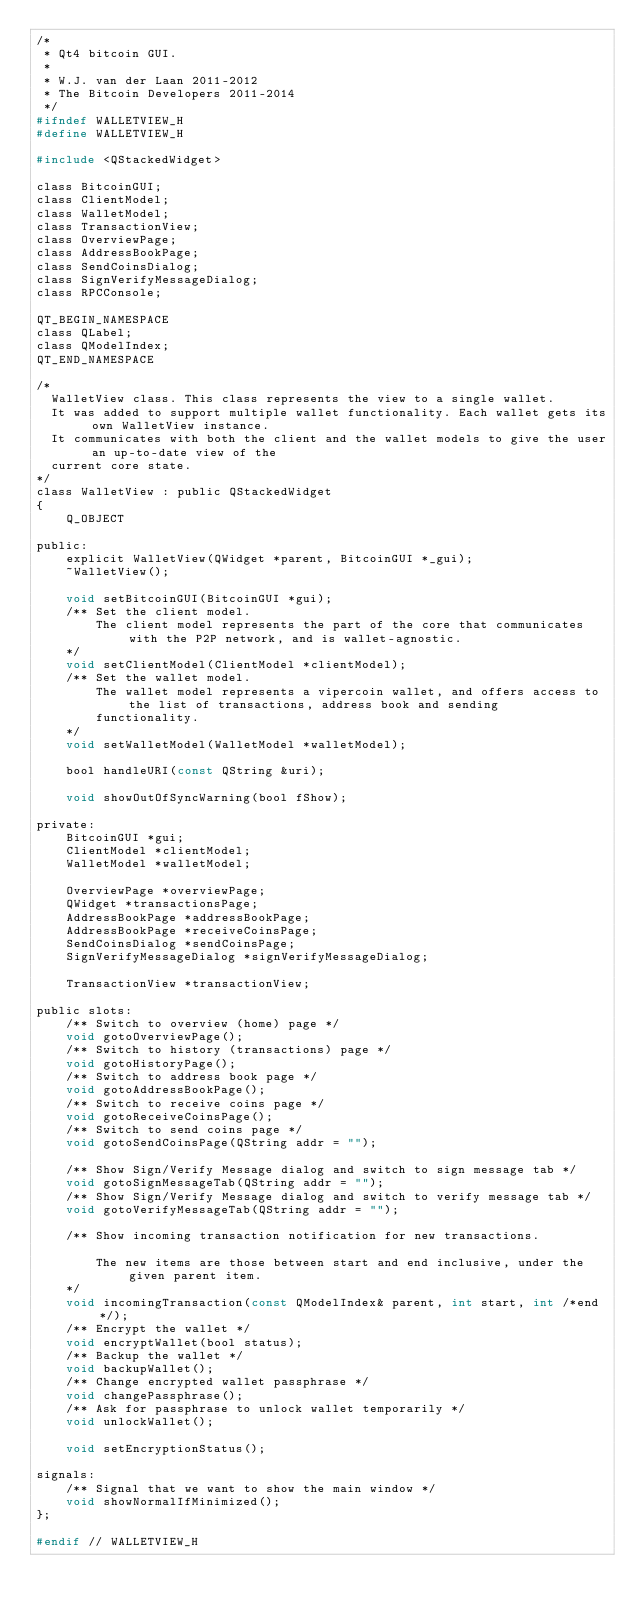Convert code to text. <code><loc_0><loc_0><loc_500><loc_500><_C_>/*
 * Qt4 bitcoin GUI.
 *
 * W.J. van der Laan 2011-2012
 * The Bitcoin Developers 2011-2014
 */
#ifndef WALLETVIEW_H
#define WALLETVIEW_H

#include <QStackedWidget>

class BitcoinGUI;
class ClientModel;
class WalletModel;
class TransactionView;
class OverviewPage;
class AddressBookPage;
class SendCoinsDialog;
class SignVerifyMessageDialog;
class RPCConsole;

QT_BEGIN_NAMESPACE
class QLabel;
class QModelIndex;
QT_END_NAMESPACE

/*
  WalletView class. This class represents the view to a single wallet.
  It was added to support multiple wallet functionality. Each wallet gets its own WalletView instance.
  It communicates with both the client and the wallet models to give the user an up-to-date view of the
  current core state.
*/
class WalletView : public QStackedWidget
{
    Q_OBJECT

public:
    explicit WalletView(QWidget *parent, BitcoinGUI *_gui);
    ~WalletView();

    void setBitcoinGUI(BitcoinGUI *gui);
    /** Set the client model.
        The client model represents the part of the core that communicates with the P2P network, and is wallet-agnostic.
    */
    void setClientModel(ClientModel *clientModel);
    /** Set the wallet model.
        The wallet model represents a vipercoin wallet, and offers access to the list of transactions, address book and sending
        functionality.
    */
    void setWalletModel(WalletModel *walletModel);

    bool handleURI(const QString &uri);

    void showOutOfSyncWarning(bool fShow);

private:
    BitcoinGUI *gui;
    ClientModel *clientModel;
    WalletModel *walletModel;

    OverviewPage *overviewPage;
    QWidget *transactionsPage;
    AddressBookPage *addressBookPage;
    AddressBookPage *receiveCoinsPage;
    SendCoinsDialog *sendCoinsPage;
    SignVerifyMessageDialog *signVerifyMessageDialog;

    TransactionView *transactionView;

public slots:
    /** Switch to overview (home) page */
    void gotoOverviewPage();
    /** Switch to history (transactions) page */
    void gotoHistoryPage();
    /** Switch to address book page */
    void gotoAddressBookPage();
    /** Switch to receive coins page */
    void gotoReceiveCoinsPage();
    /** Switch to send coins page */
    void gotoSendCoinsPage(QString addr = "");

    /** Show Sign/Verify Message dialog and switch to sign message tab */
    void gotoSignMessageTab(QString addr = "");
    /** Show Sign/Verify Message dialog and switch to verify message tab */
    void gotoVerifyMessageTab(QString addr = "");

    /** Show incoming transaction notification for new transactions.

        The new items are those between start and end inclusive, under the given parent item.
    */
    void incomingTransaction(const QModelIndex& parent, int start, int /*end*/);
    /** Encrypt the wallet */
    void encryptWallet(bool status);
    /** Backup the wallet */
    void backupWallet();
    /** Change encrypted wallet passphrase */
    void changePassphrase();
    /** Ask for passphrase to unlock wallet temporarily */
    void unlockWallet();

    void setEncryptionStatus();

signals:
    /** Signal that we want to show the main window */
    void showNormalIfMinimized();
};

#endif // WALLETVIEW_H
</code> 